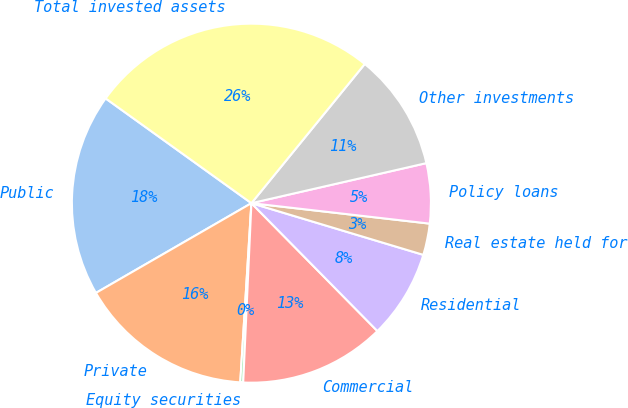Convert chart to OTSL. <chart><loc_0><loc_0><loc_500><loc_500><pie_chart><fcel>Public<fcel>Private<fcel>Equity securities<fcel>Commercial<fcel>Residential<fcel>Real estate held for<fcel>Policy loans<fcel>Other investments<fcel>Total invested assets<nl><fcel>18.25%<fcel>15.68%<fcel>0.26%<fcel>13.11%<fcel>7.97%<fcel>2.83%<fcel>5.4%<fcel>10.54%<fcel>25.96%<nl></chart> 